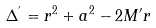<formula> <loc_0><loc_0><loc_500><loc_500>\Delta ^ { ^ { \prime } } = r ^ { 2 } + a ^ { 2 } - 2 M ^ { \prime } r</formula> 